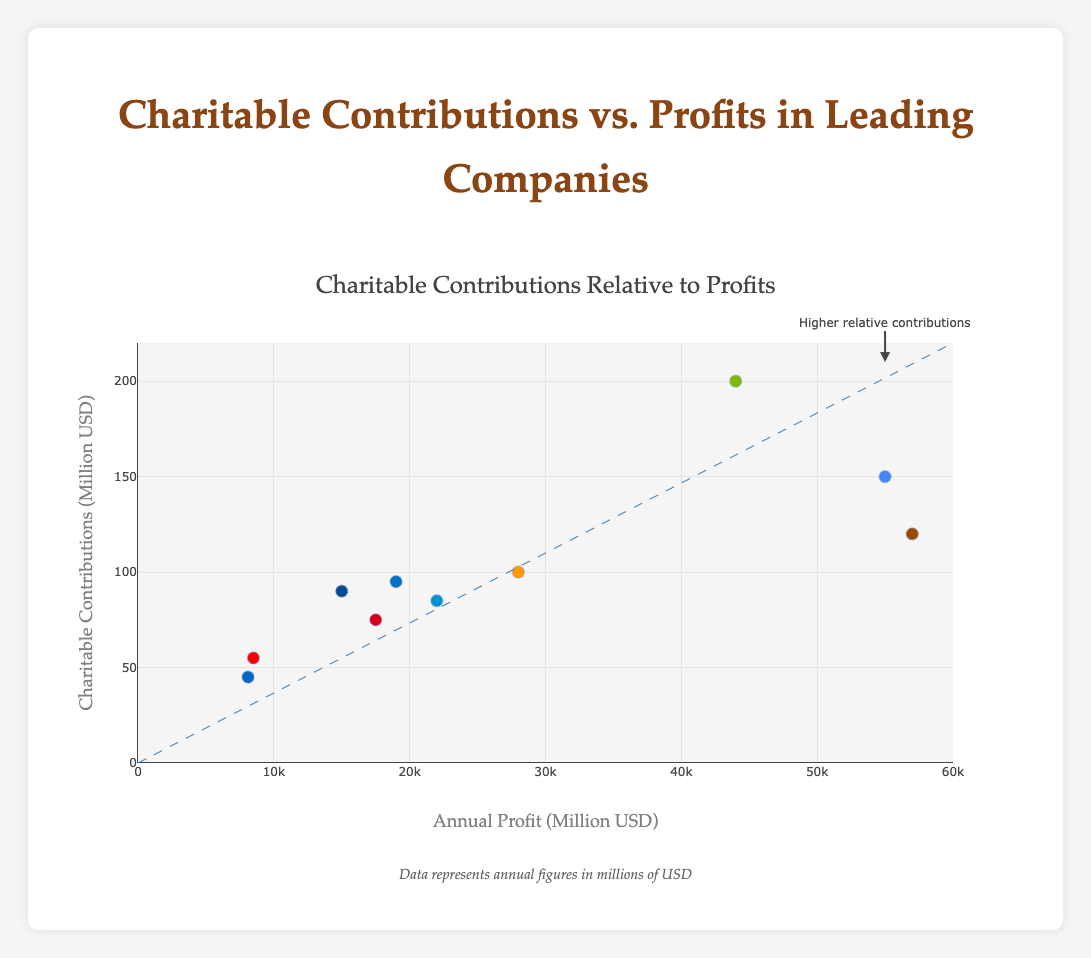**1. How many companies are represented in this chart?** The chart shows 10 data points, each representing a company. Since each point is labeled with a unique company name, there are 10 companies in the chart.
Answer: 10 **2. What is the title of the chart?** The title is displayed at the top of the chart and reads, "Charitable Contributions Relative to Profits."
Answer: Charitable Contributions Relative to Profits **3. What does the x-axis represent?** The x-axis, with the label "Annual Profit (Million USD)," shows the profit in millions of USD.
Answer: Annual Profit (Million USD) **4. What is represented by the y-axis?** The y-axis, labeled "Charitable Contributions (Million USD)," represents the charitable contributions in millions of USD.
Answer: Charitable Contributions (Million USD) **5. What is the highest value on the y-axis?** The highest value on the y-axis is 220 million USD for charitable contributions.
Answer: 220 million USD **6. What is the average profit of Google LLC and Intel Corporation combined?** To find the average profit, add the profits of Google (55000 million USD) and Intel (19000 million USD) and then divide by 2: 
(55000 + 19000) / 2 = 74000 / 2 = 37000 million USD.
Answer: 37000 million USD **7. What is the total amount of charitable contributions made by Apple Inc. and Microsoft Corporation?** Apple Inc. contributed 120 million USD, and Microsoft Corporation contributed 200 million USD. Adding these values gives: 120 + 200 = 320 million USD.
Answer: 320 million USD **8. What is the difference in profits between Amazon.com Inc. and Pfizer Inc.?** Amazon.com Inc.'s profit is 28000 million USD, and Pfizer Inc.'s profit is 22000 million USD. The difference is: 28000 - 22000 = 6000 million USD.
Answer: 6000 million USD **9. Which company has the highest charitable contributions?** By examining the y-values, Microsoft Corporation has the highest charitable contribution at 200 million USD.
Answer: Microsoft Corporation **10. Which company shows the smallest annual profit?** The company with the smallest profit, based on the x-values, is PepsiCo Inc. with 8100 million USD.
Answer: PepsiCo Inc **11. Which company, according to the annotation, lies close to showing 'Higher relative contributions'?** The annotation appears near Google LLC and points toward it with an arrow, indicating that Google LLC is close to showing higher relative contributions in relative terms.
Answer: Google LLC **12. What does the dashed line in the chart represent?** The dashed line generally represents a trend or an ideal balance. In this case, it indicates a line of possible relative proportions between profits and charitable contributions.
Answer: A trend or ideal balance line **13. Are there any companies that deviate significantly from the dashed line, indicating higher charitable contributions relative to their profits?** Microsoft Corporation and Google LLC appear to be above the dashed line, showing higher charitable contributions relative to their profits.
Answer: Microsoft Corporation and Google LLC 